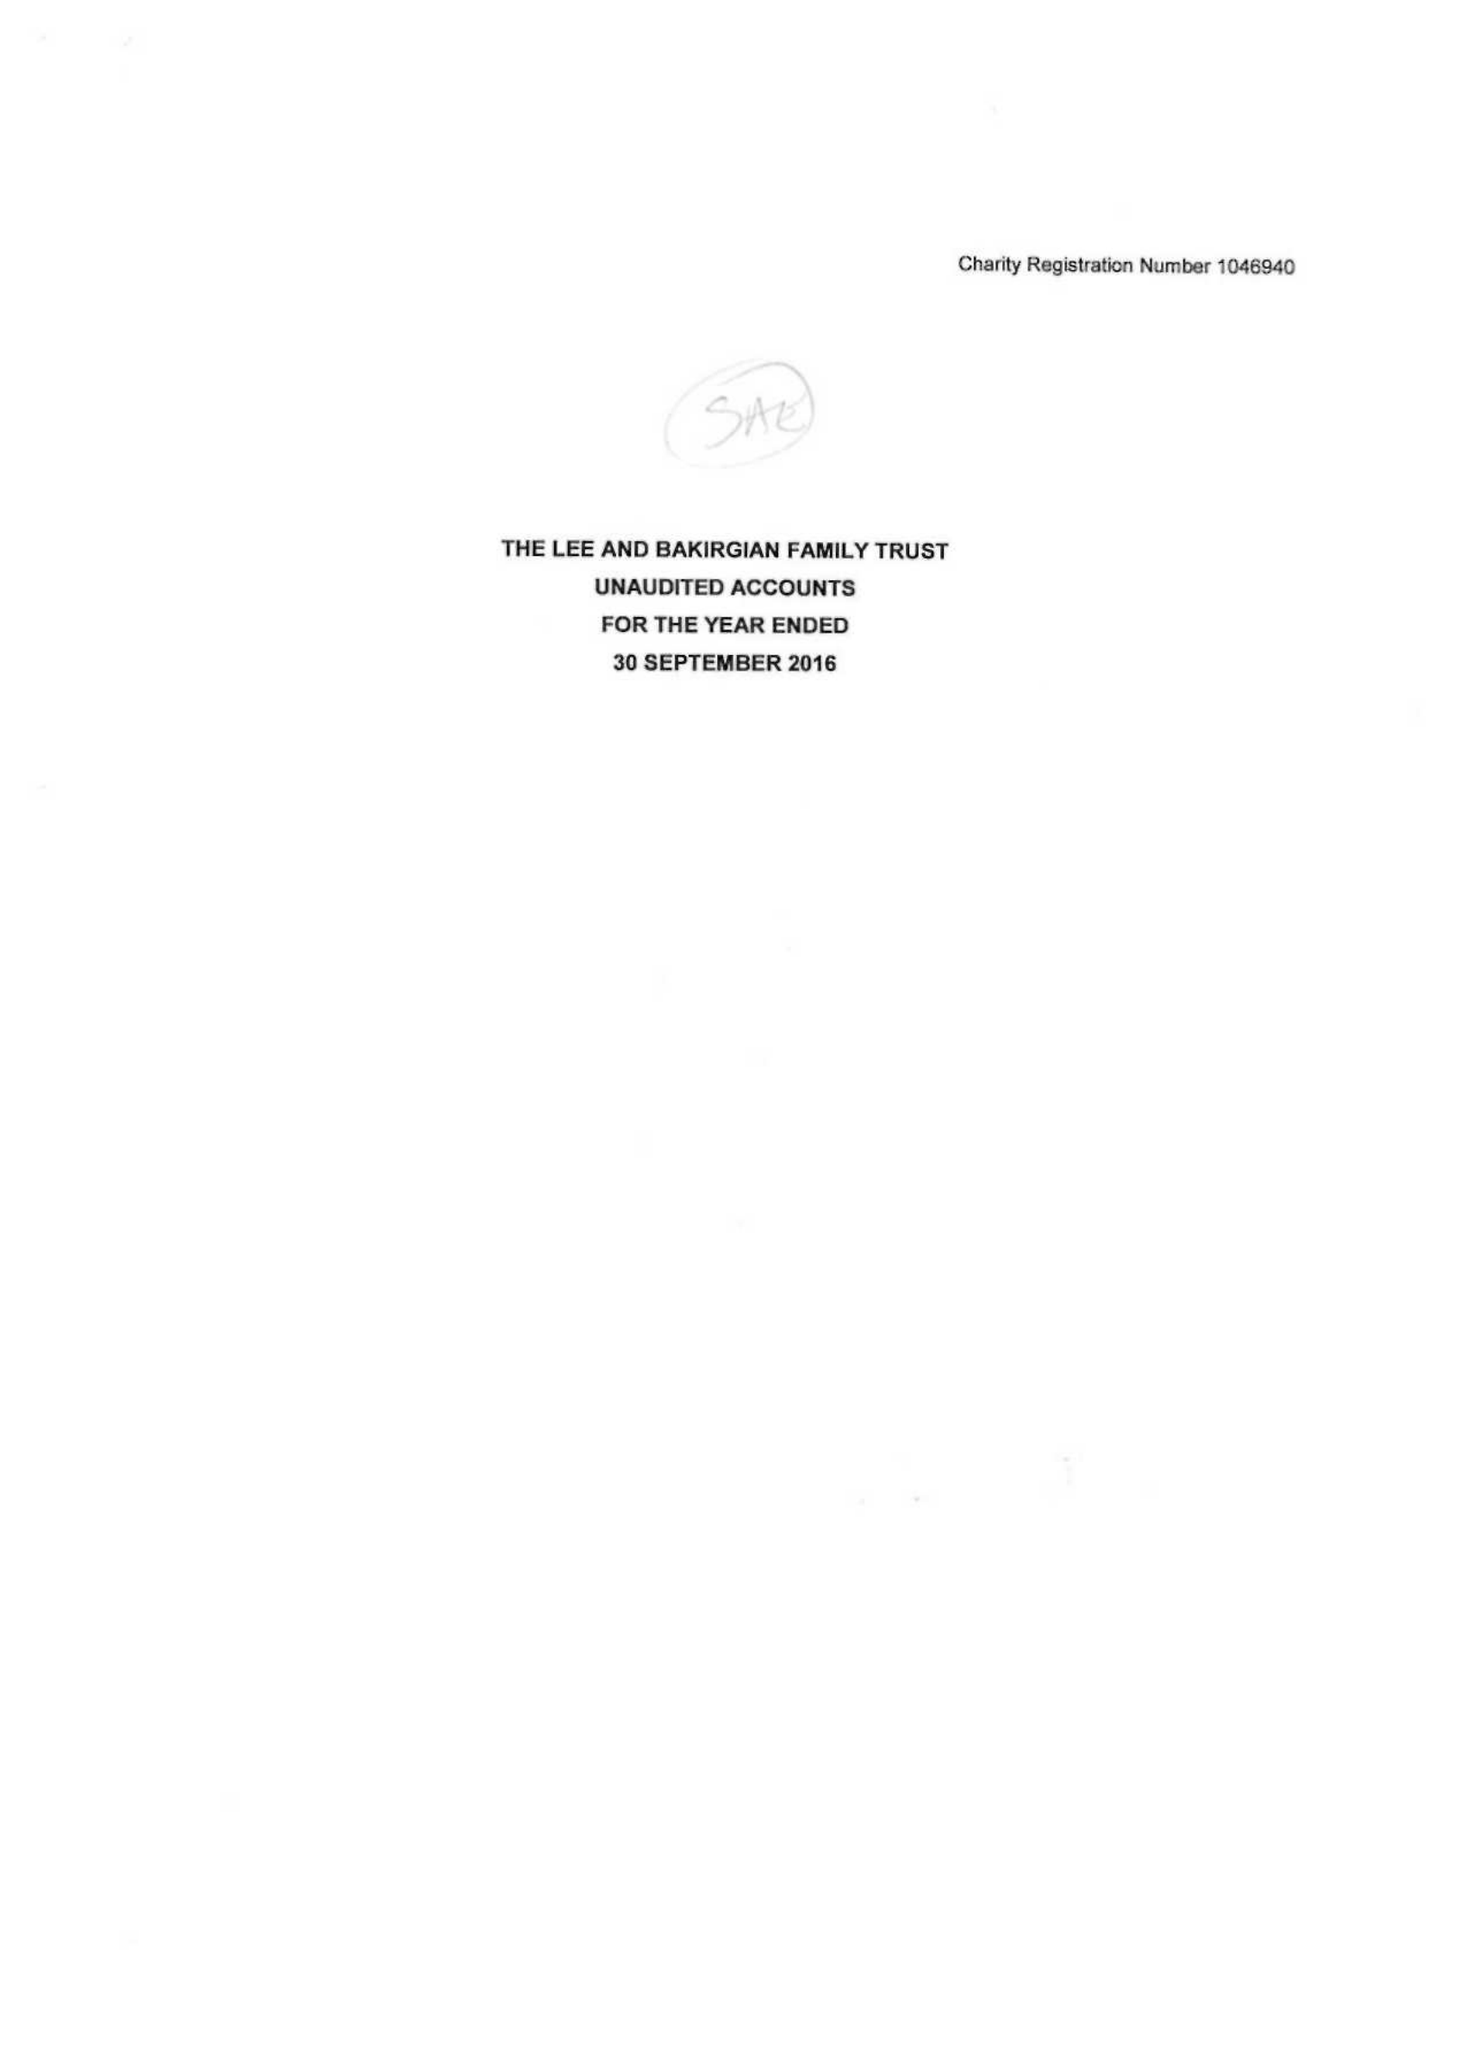What is the value for the charity_number?
Answer the question using a single word or phrase. 1046940 